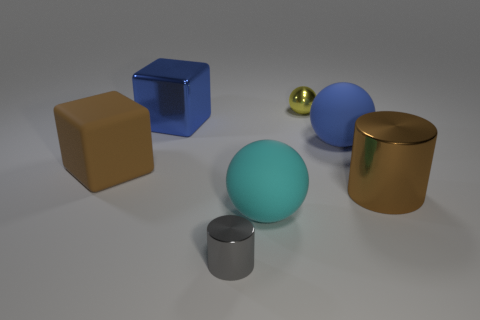Add 2 red rubber cylinders. How many objects exist? 9 Subtract all cylinders. How many objects are left? 5 Subtract all big gray shiny cubes. Subtract all large blue cubes. How many objects are left? 6 Add 6 large blue rubber spheres. How many large blue rubber spheres are left? 7 Add 5 big brown metallic things. How many big brown metallic things exist? 6 Subtract 0 green cylinders. How many objects are left? 7 